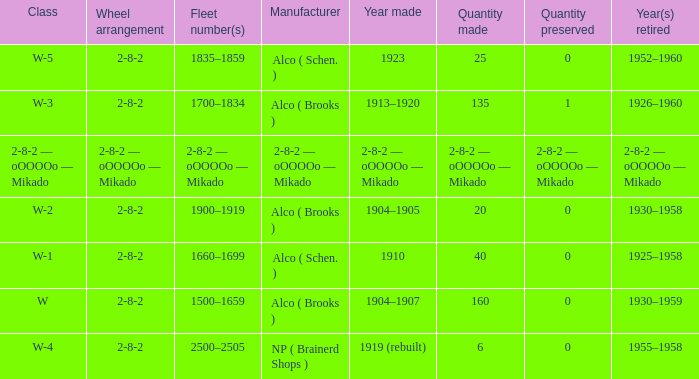What is the locomotive class that has a wheel arrangement of 2-8-2 and a quantity made of 25? W-5. 